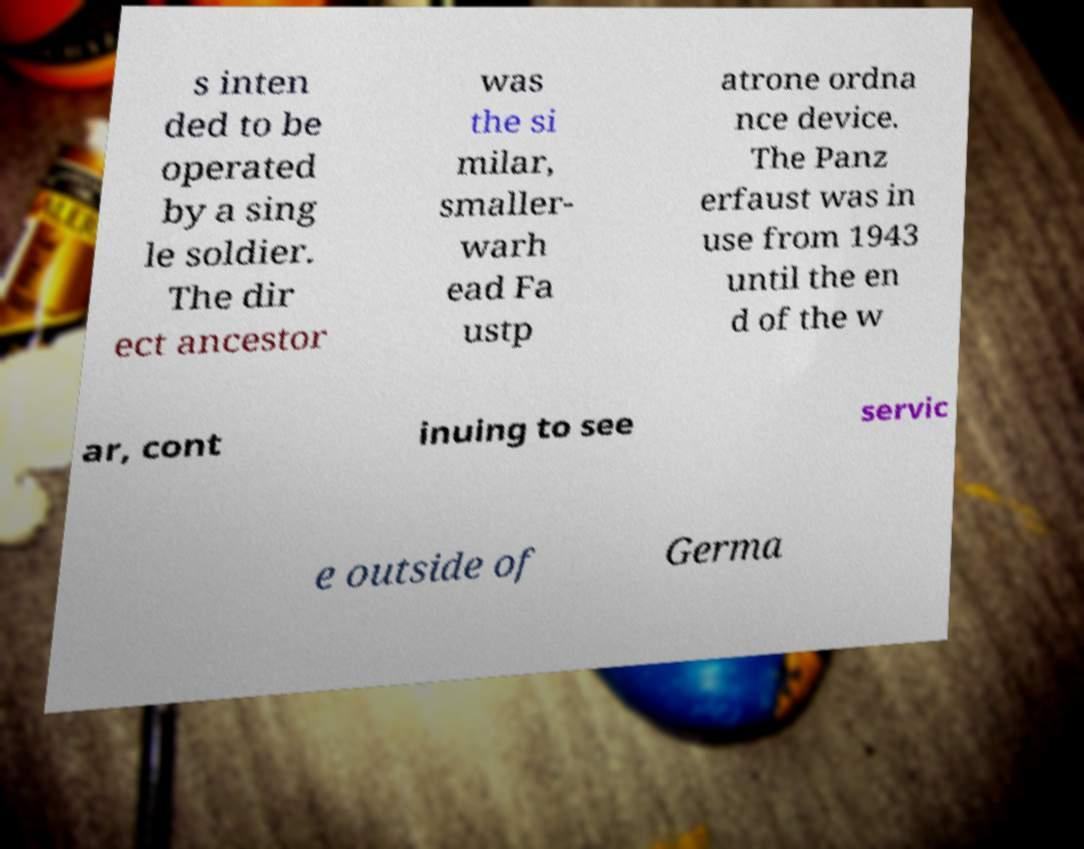I need the written content from this picture converted into text. Can you do that? s inten ded to be operated by a sing le soldier. The dir ect ancestor was the si milar, smaller- warh ead Fa ustp atrone ordna nce device. The Panz erfaust was in use from 1943 until the en d of the w ar, cont inuing to see servic e outside of Germa 